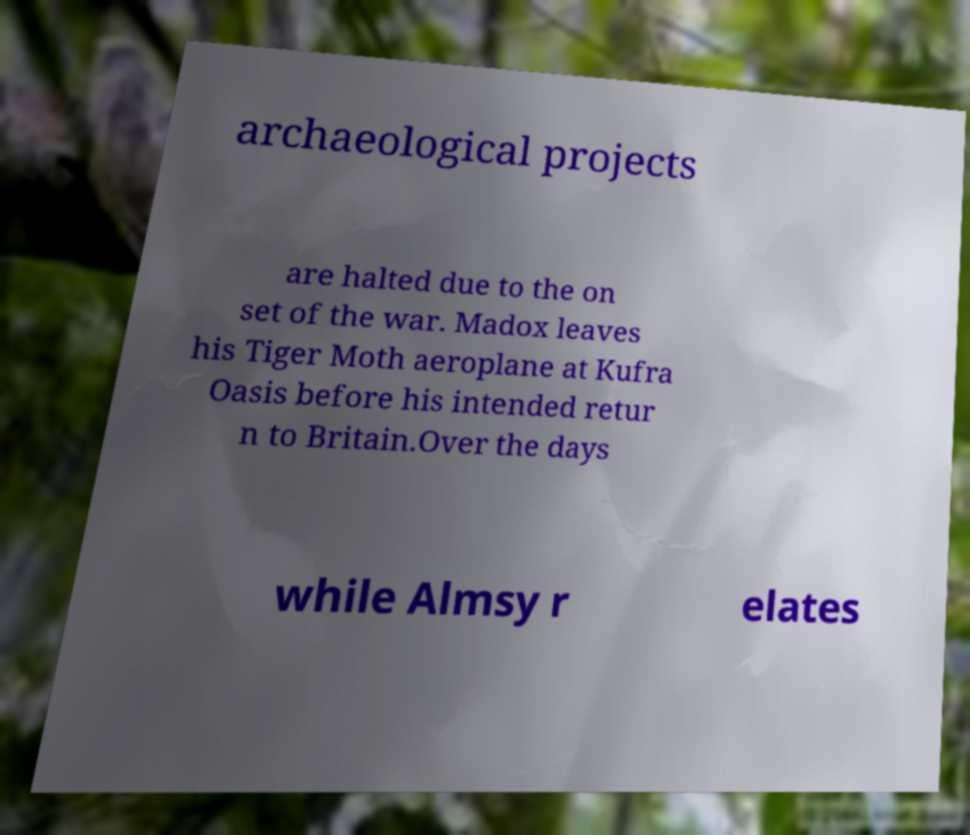Please identify and transcribe the text found in this image. archaeological projects are halted due to the on set of the war. Madox leaves his Tiger Moth aeroplane at Kufra Oasis before his intended retur n to Britain.Over the days while Almsy r elates 